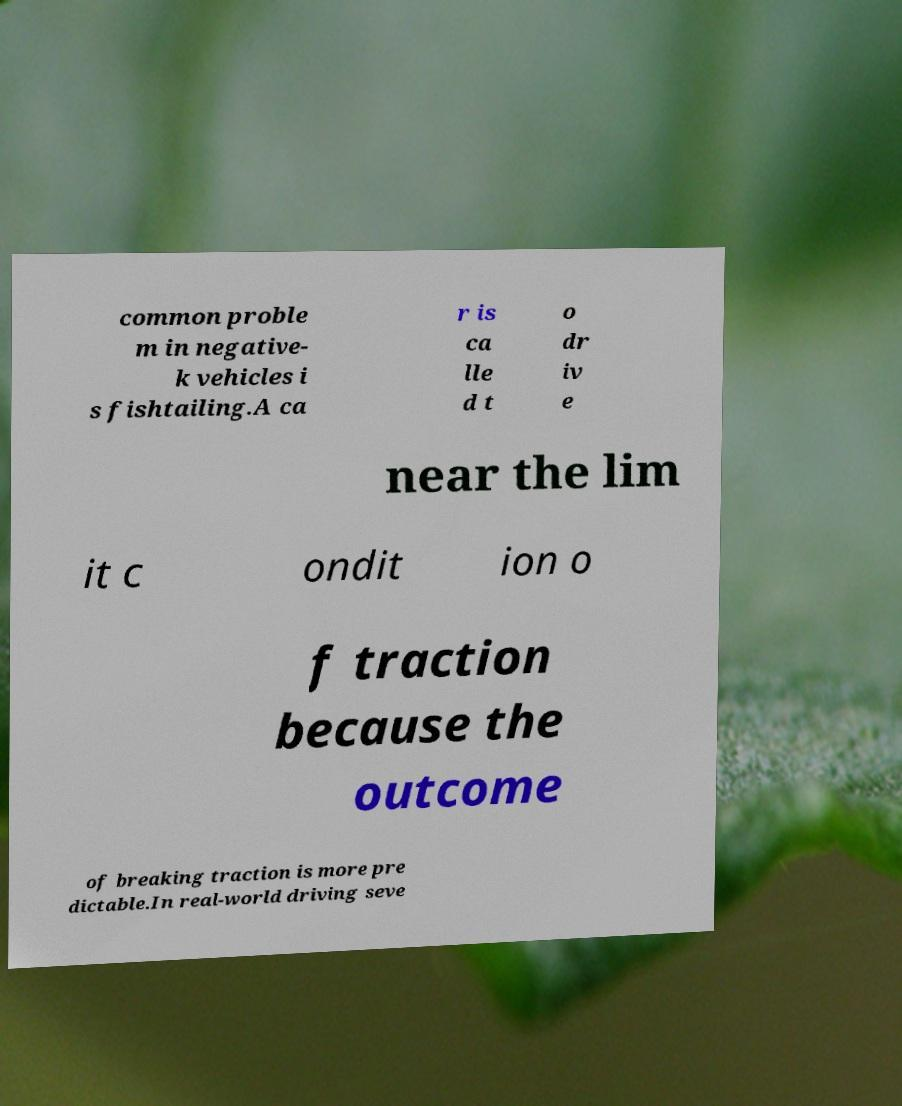Please read and relay the text visible in this image. What does it say? common proble m in negative- k vehicles i s fishtailing.A ca r is ca lle d t o dr iv e near the lim it c ondit ion o f traction because the outcome of breaking traction is more pre dictable.In real-world driving seve 